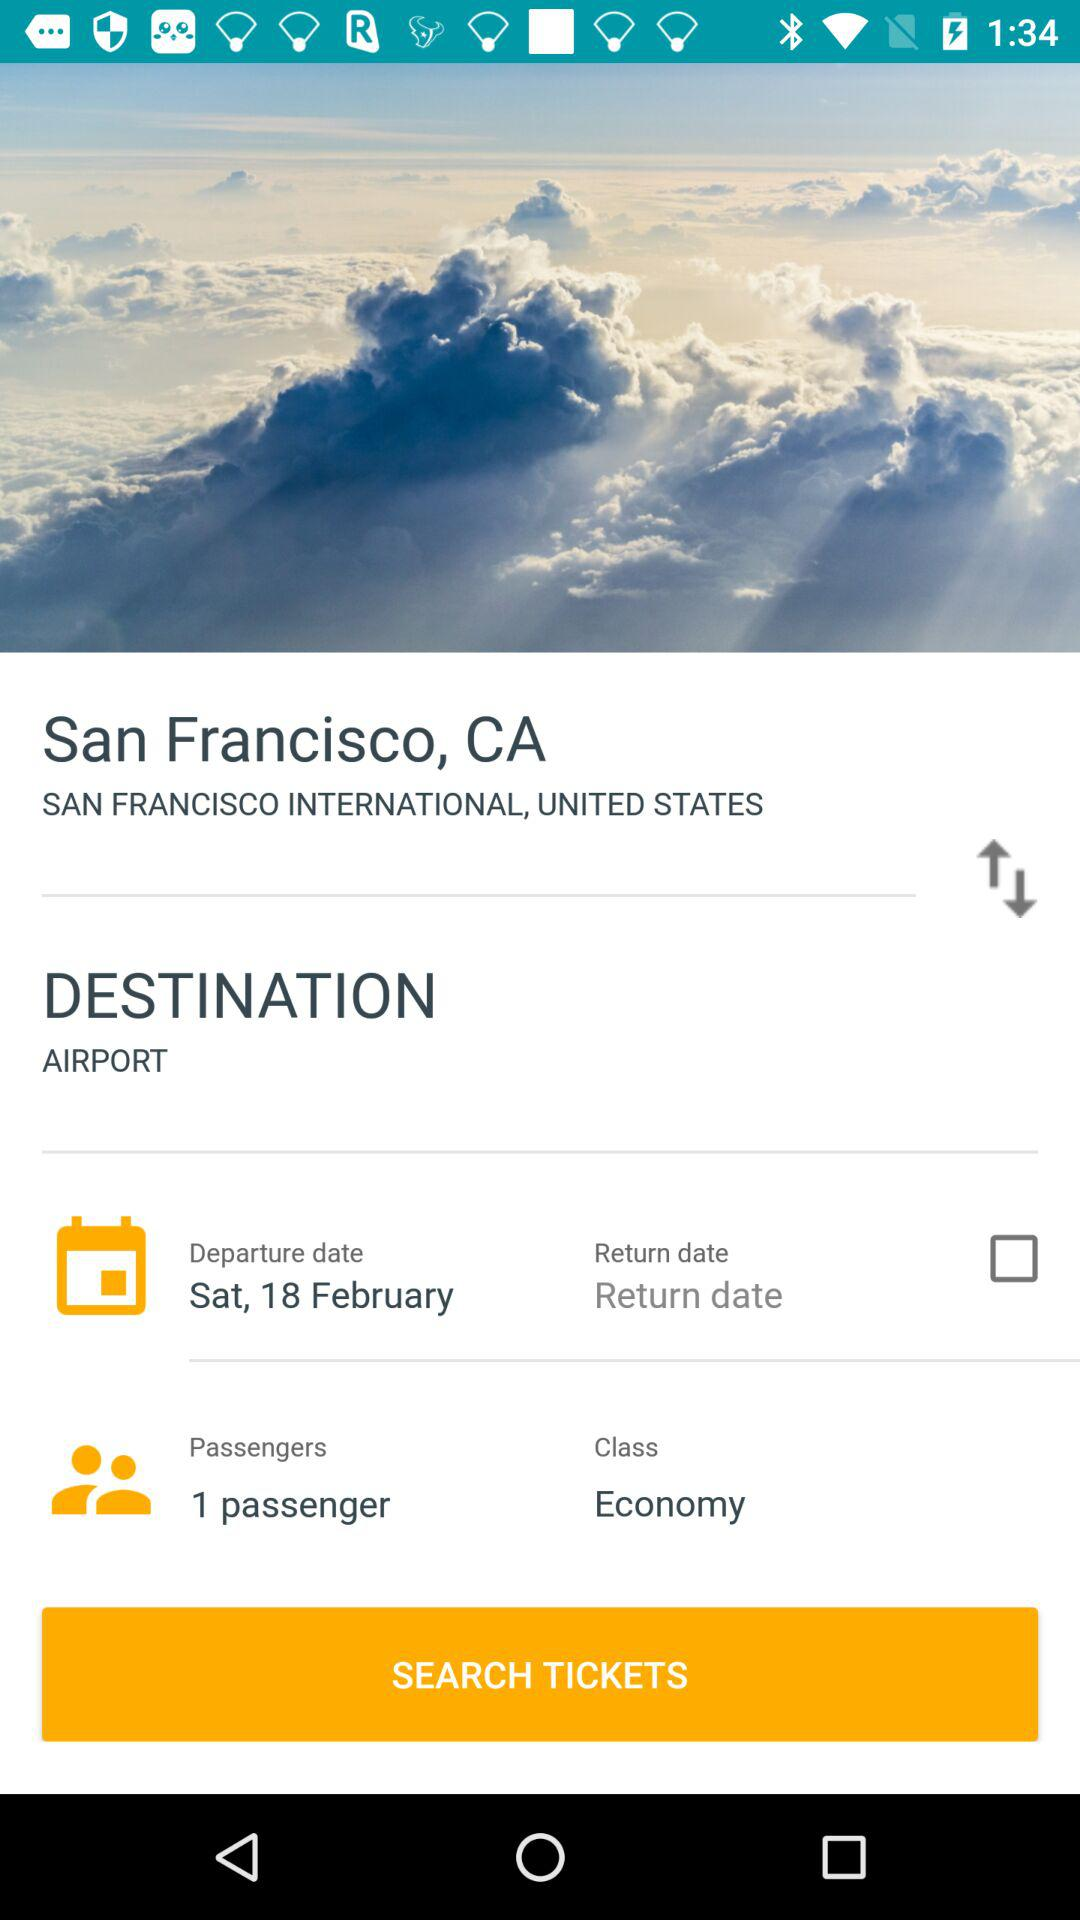What's the status of return date? The status is "off". 